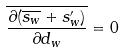<formula> <loc_0><loc_0><loc_500><loc_500>\overline { \frac { \partial ( \overline { s _ { w } } + s _ { w } ^ { \prime } ) } { \partial d _ { w } } } = 0</formula> 